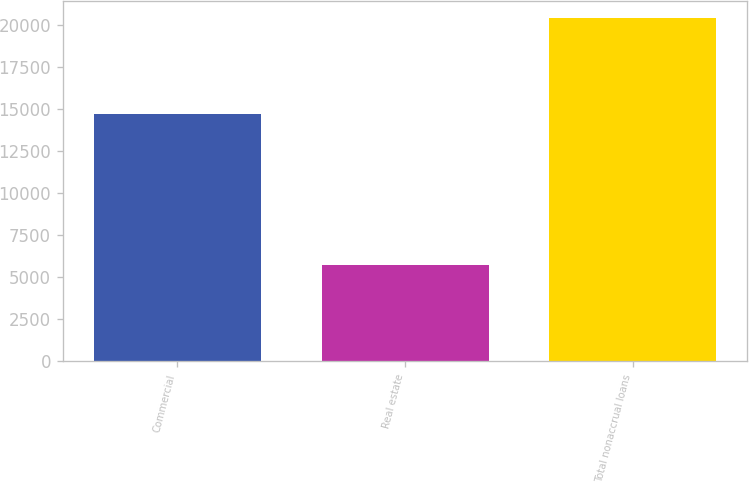Convert chart to OTSL. <chart><loc_0><loc_0><loc_500><loc_500><bar_chart><fcel>Commercial<fcel>Real estate<fcel>Total nonaccrual loans<nl><fcel>14688<fcel>5723<fcel>20411<nl></chart> 